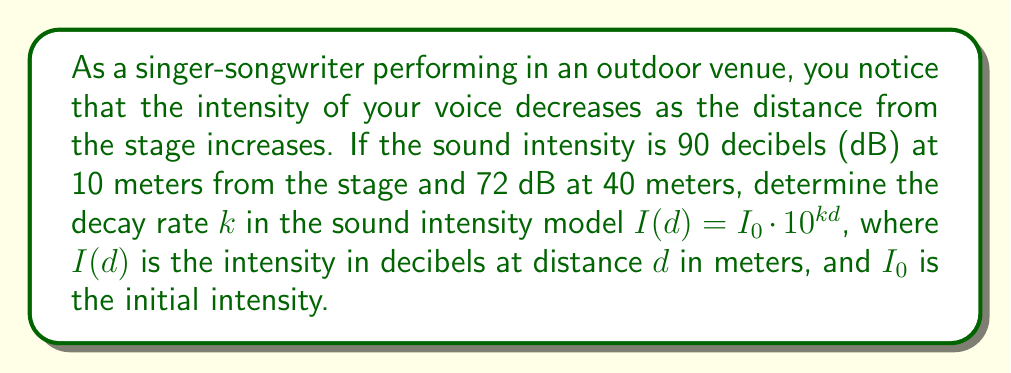Provide a solution to this math problem. Let's approach this step-by-step:

1) We're given that the sound intensity model follows the equation:
   $I(d) = I_0 \cdot 10^{kd}$

2) We have two data points:
   At $d_1 = 10$ m, $I(10) = 90$ dB
   At $d_2 = 40$ m, $I(40) = 72$ dB

3) Let's use these points to set up two equations:
   $90 = I_0 \cdot 10^{10k}$
   $72 = I_0 \cdot 10^{40k}$

4) Divide the second equation by the first:
   $\frac{72}{90} = \frac{I_0 \cdot 10^{40k}}{I_0 \cdot 10^{10k}}$

5) The $I_0$ terms cancel out:
   $\frac{72}{90} = \frac{10^{40k}}{10^{10k}} = 10^{30k}$

6) Take the logarithm of both sides:
   $\log(\frac{72}{90}) = \log(10^{30k})$

7) Using the logarithm property $\log(a^b) = b\log(a)$:
   $\log(\frac{72}{90}) = 30k \log(10) = 30k$

8) Solve for $k$:
   $k = \frac{\log(\frac{72}{90})}{30}$

9) Calculate the value:
   $k = \frac{\log(0.8)}{30} \approx -0.00251$

The negative value indicates that the intensity decreases with distance, as expected.
Answer: $k \approx -0.00251$ 